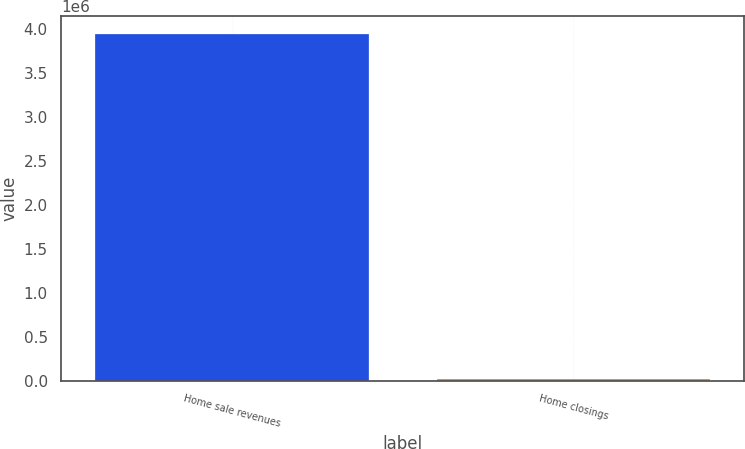<chart> <loc_0><loc_0><loc_500><loc_500><bar_chart><fcel>Home sale revenues<fcel>Home closings<nl><fcel>3.95074e+06<fcel>15275<nl></chart> 